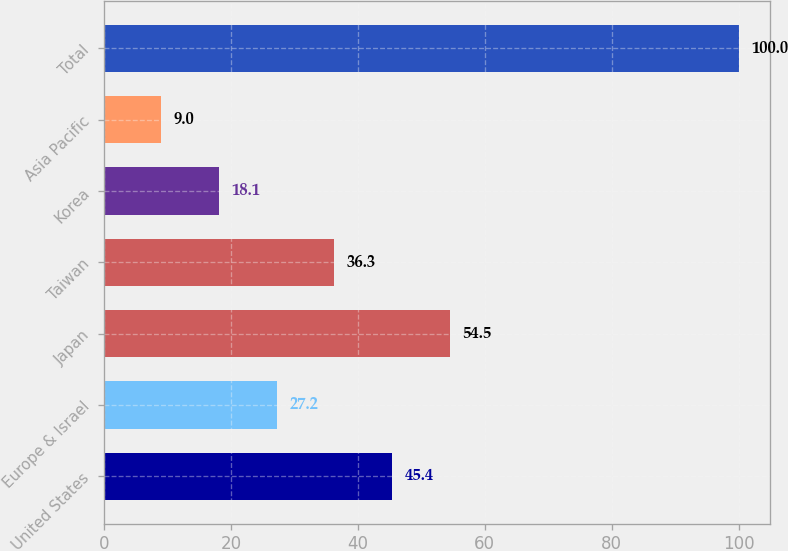<chart> <loc_0><loc_0><loc_500><loc_500><bar_chart><fcel>United States<fcel>Europe & Israel<fcel>Japan<fcel>Taiwan<fcel>Korea<fcel>Asia Pacific<fcel>Total<nl><fcel>45.4<fcel>27.2<fcel>54.5<fcel>36.3<fcel>18.1<fcel>9<fcel>100<nl></chart> 